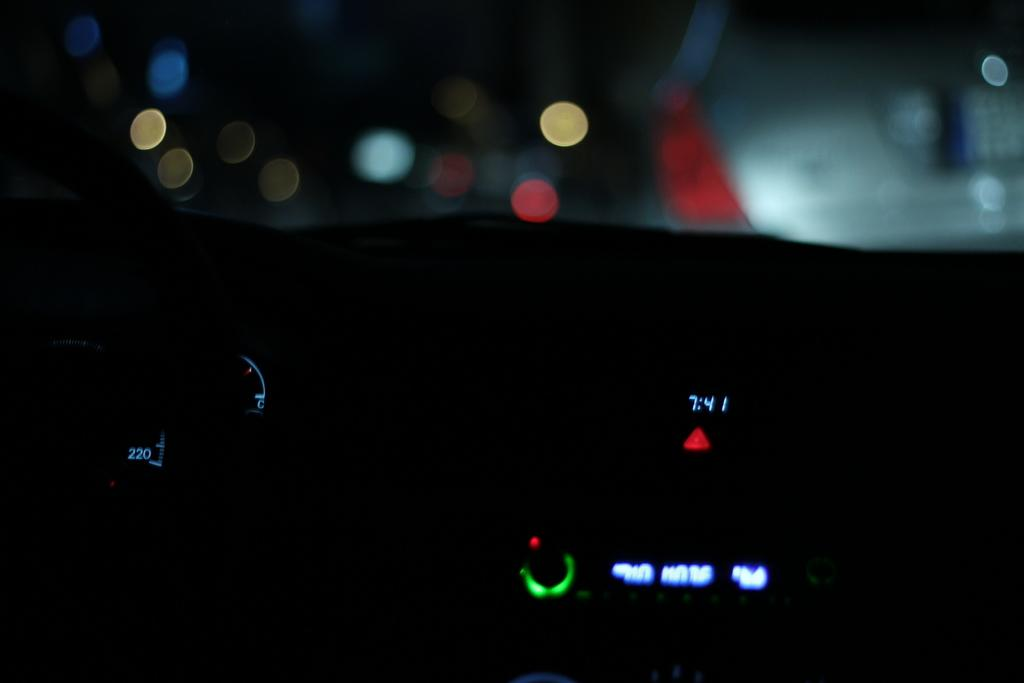What type of instrument is present in the image? There is a speedometer and a clock in the image. What is the context of these instruments? They are likely part of a vehicle's dashboard. What else can be seen in the background of the image? There is a car and light visible in the background. How many clovers can be seen growing near the speedometer in the image? There are no clovers present in the image. Can you describe the friends sitting in the car in the background of the image? There is no mention of friends or a car with people inside in the provided facts. 